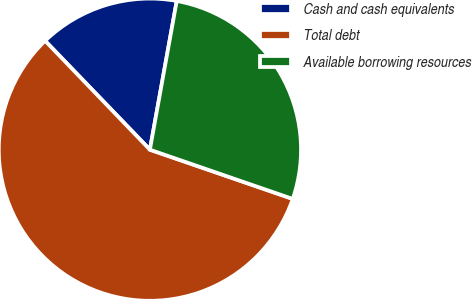Convert chart. <chart><loc_0><loc_0><loc_500><loc_500><pie_chart><fcel>Cash and cash equivalents<fcel>Total debt<fcel>Available borrowing resources<nl><fcel>15.04%<fcel>57.52%<fcel>27.44%<nl></chart> 